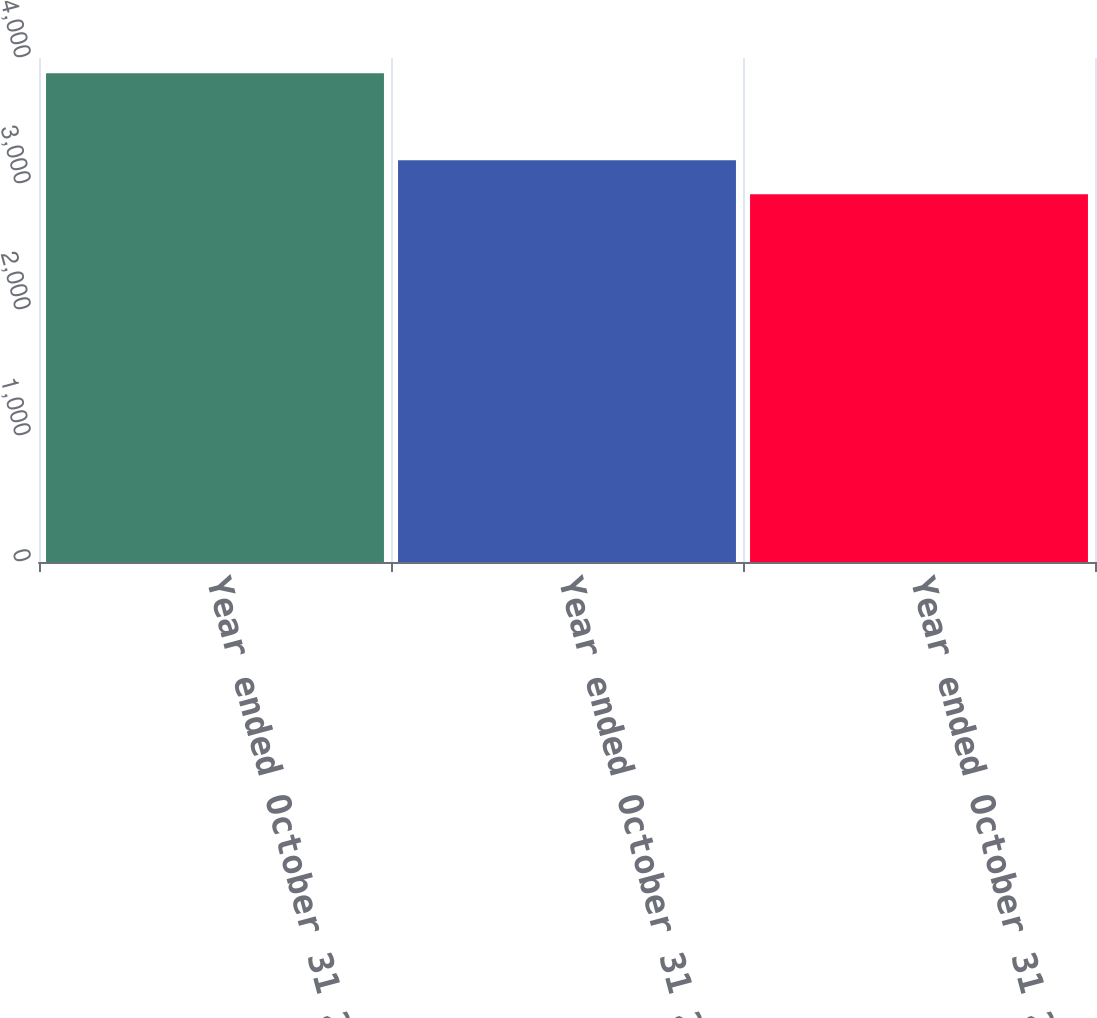Convert chart. <chart><loc_0><loc_0><loc_500><loc_500><bar_chart><fcel>Year ended October 31 2018<fcel>Year ended October 31 2017<fcel>Year ended October 31 2016<nl><fcel>3878<fcel>3189<fcel>2918<nl></chart> 